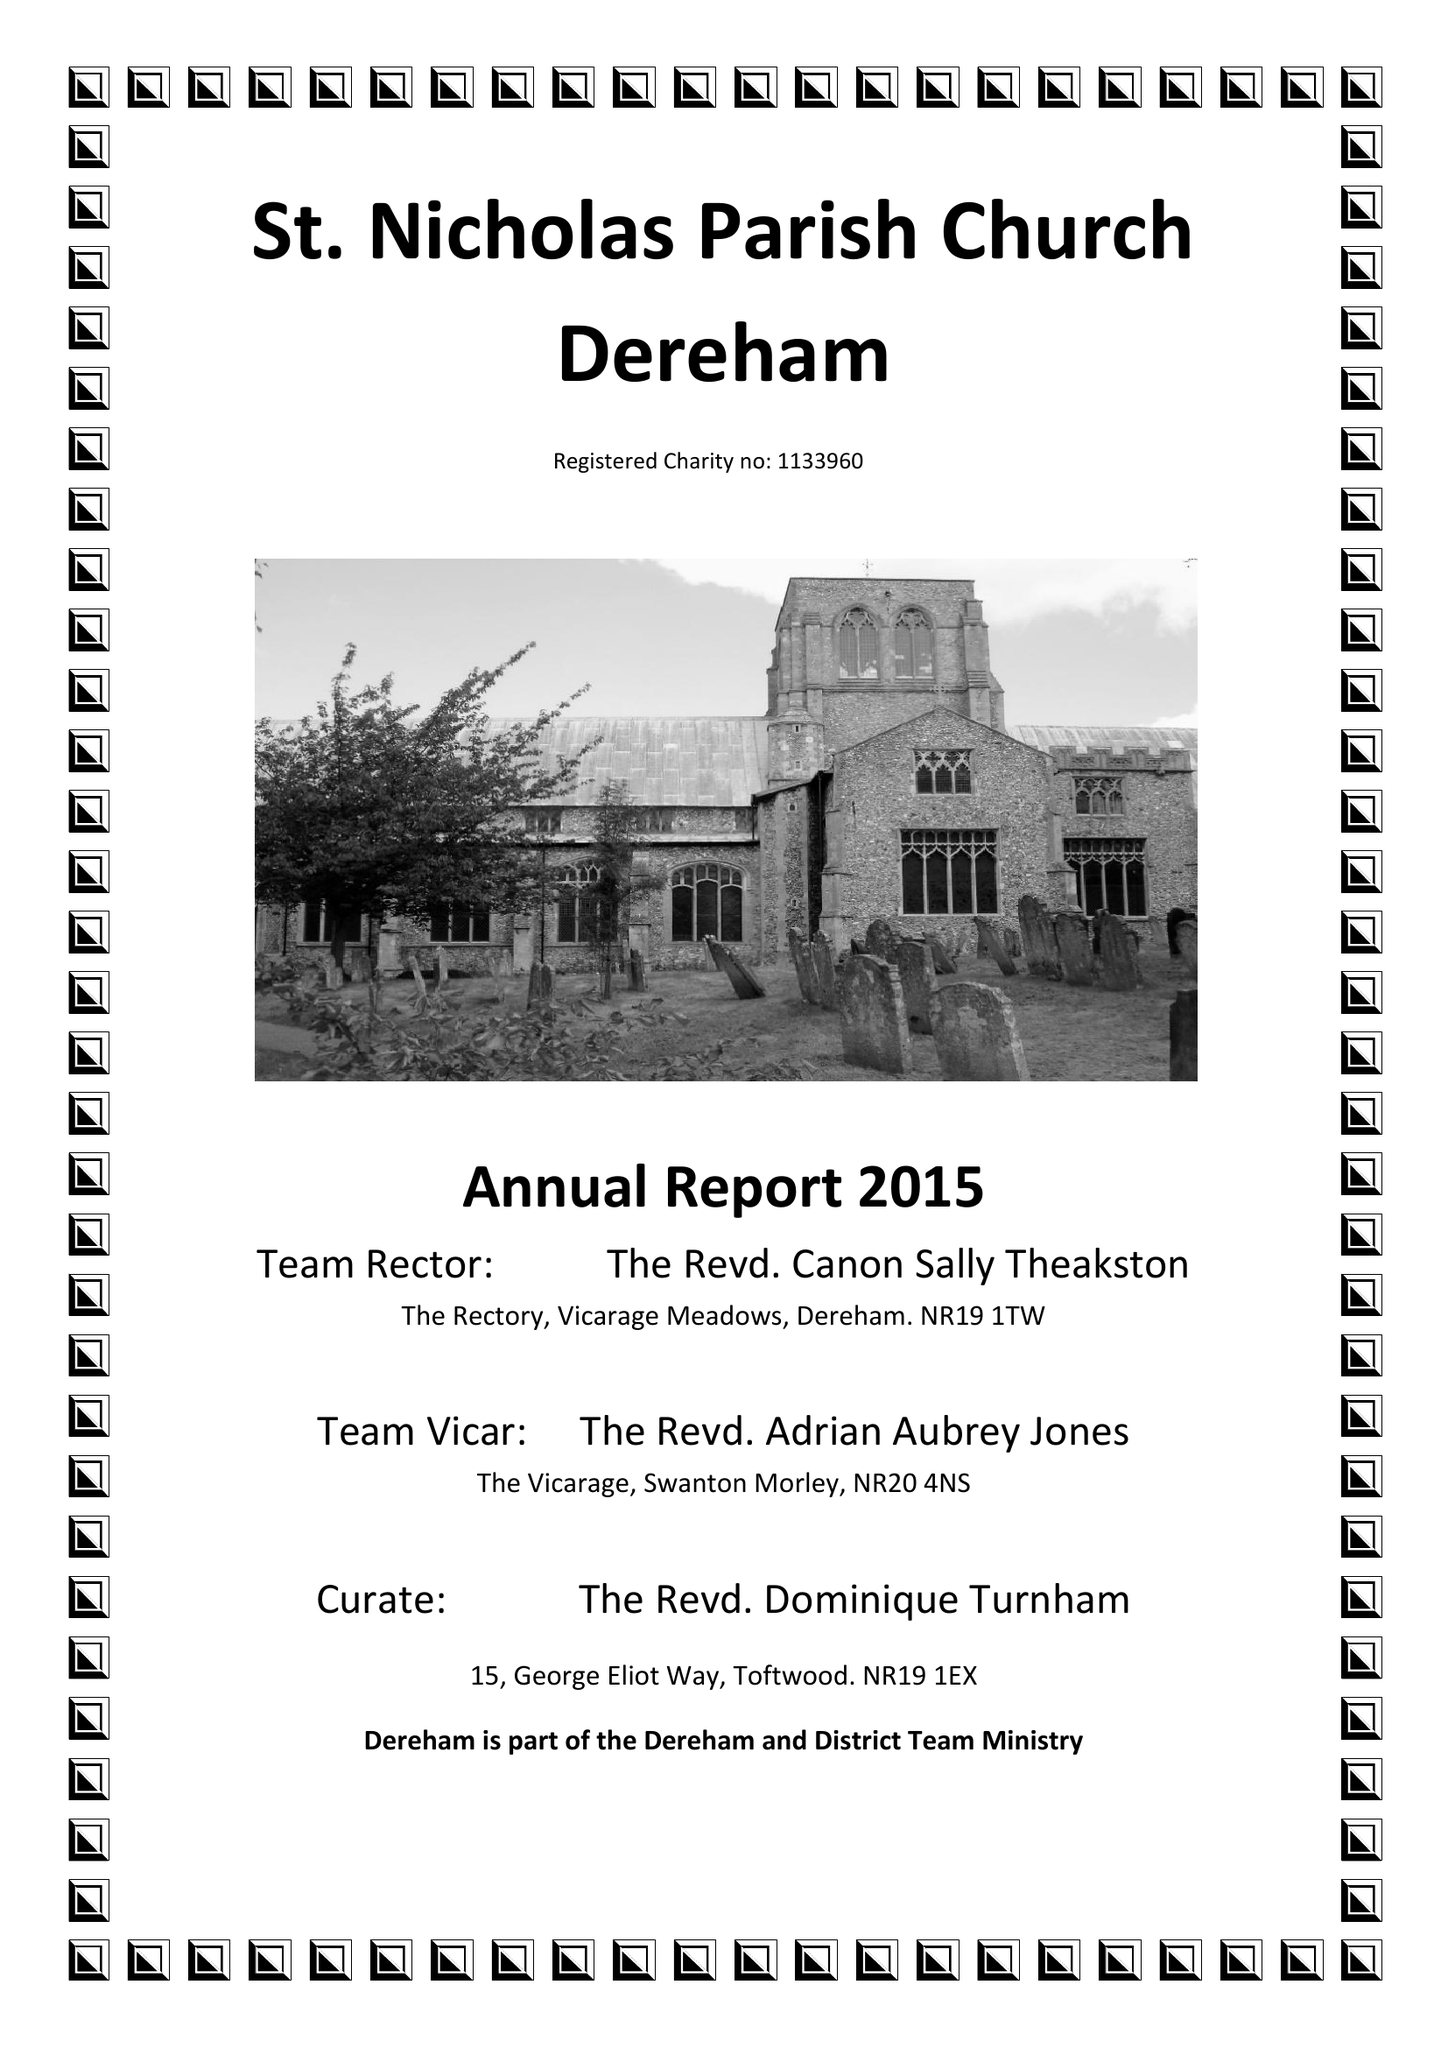What is the value for the report_date?
Answer the question using a single word or phrase. 2015-12-31 